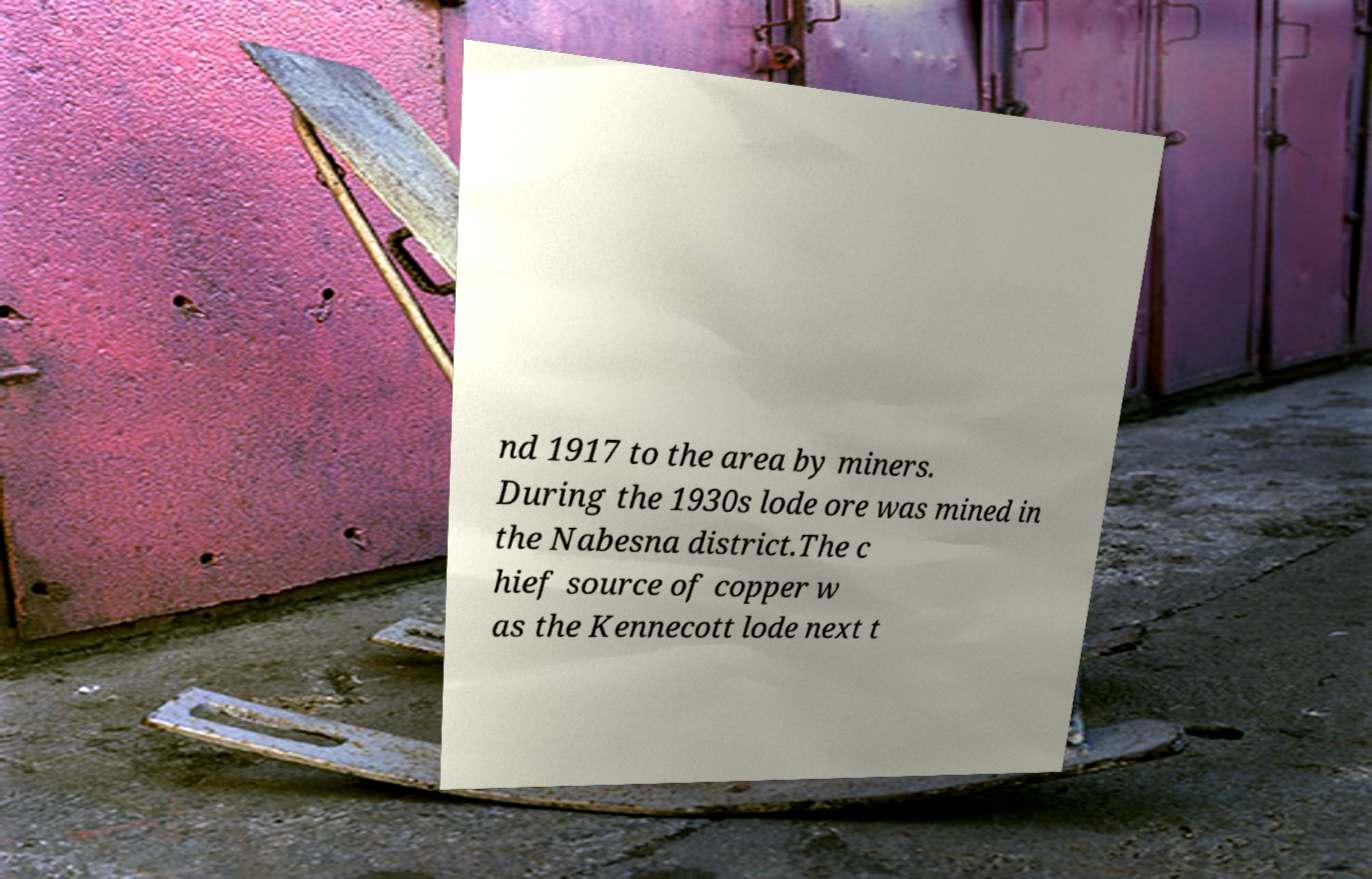Could you assist in decoding the text presented in this image and type it out clearly? nd 1917 to the area by miners. During the 1930s lode ore was mined in the Nabesna district.The c hief source of copper w as the Kennecott lode next t 